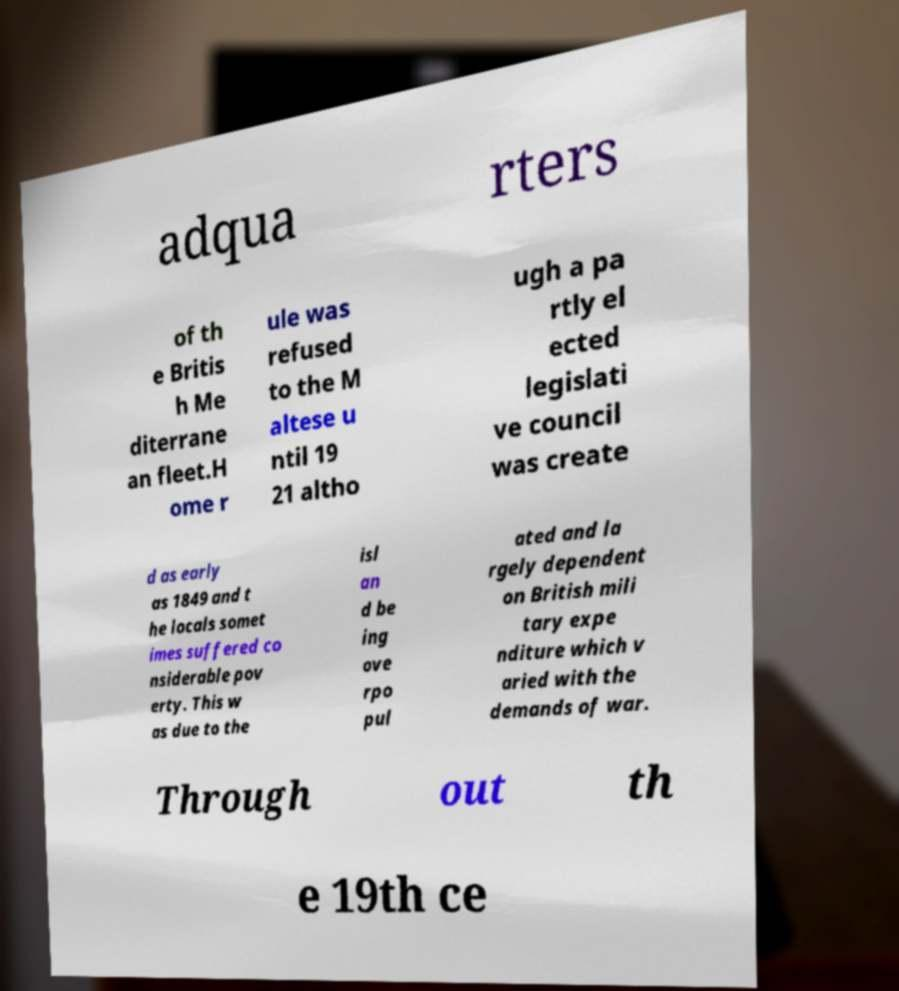Please identify and transcribe the text found in this image. adqua rters of th e Britis h Me diterrane an fleet.H ome r ule was refused to the M altese u ntil 19 21 altho ugh a pa rtly el ected legislati ve council was create d as early as 1849 and t he locals somet imes suffered co nsiderable pov erty. This w as due to the isl an d be ing ove rpo pul ated and la rgely dependent on British mili tary expe nditure which v aried with the demands of war. Through out th e 19th ce 